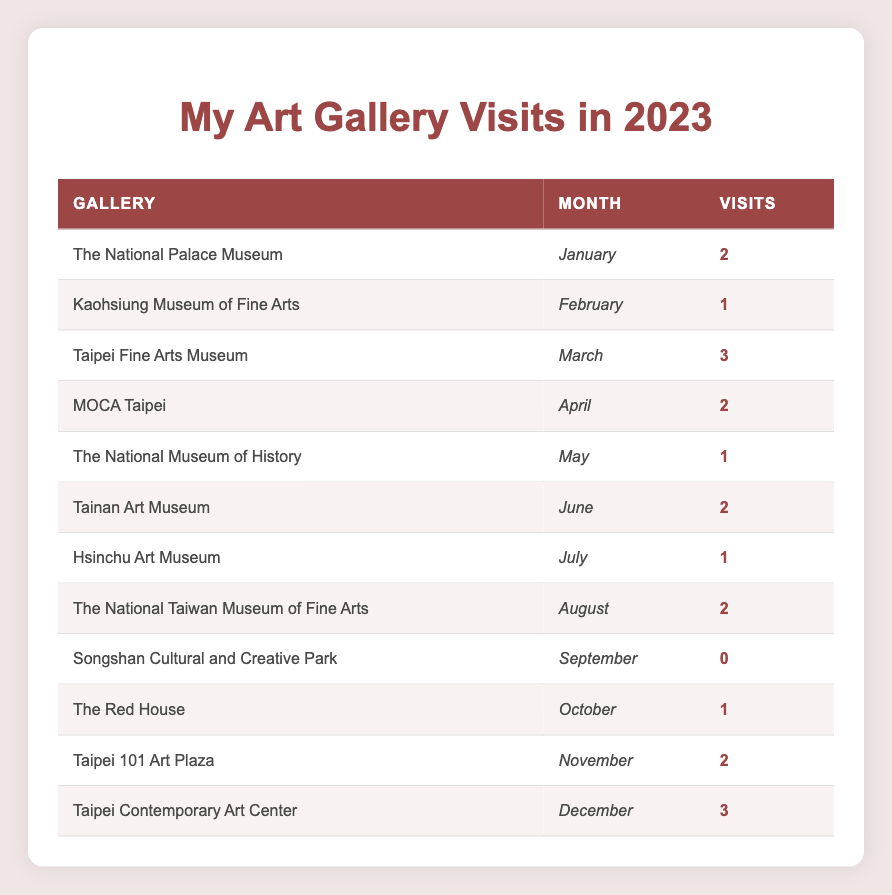What is the total number of visits Alice Chen made to art galleries from January to December? To find the total visits, I need to sum the visits from each month: 2 (Jan) + 1 (Feb) + 3 (Mar) + 2 (Apr) + 1 (May) + 2 (Jun) + 1 (Jul) + 2 (Aug) + 0 (Sep) + 1 (Oct) + 2 (Nov) + 3 (Dec) = 18 visits.
Answer: 18 Which month did Alice visit the most galleries? I can find the month with the highest number of visits by reviewing the visits for each month: March (3 visits) is the highest compared to any other month.
Answer: March Did Alice visit the Songshan Cultural and Creative Park in the past year? The table shows that there were 0 visits for Songshan Cultural and Creative Park in September, indicating no visit occurred.
Answer: No How many galleries did Alice visit with 2 or more visits in total? I count the months where visits are 2 or more: January (2), March (3), April (2), June (2), August (2), November (2), and December (3). This totals 7 months where visits were 2 or more.
Answer: 7 What was the average number of visits Alice made to galleries each month? To find the average, I divide the total number of visits (18) by the number of months (12). Thus, 18 visits / 12 months = 1.5 visits per month on average.
Answer: 1.5 Which gallery did Alice visit in October and how many times? The table shows that Alice visited The Red House in October and made 1 visit there.
Answer: The Red House, 1 visit Was the visit count higher in the second half of the year than in the first half? To verify, I sum the visits for each half: First half (January to June) = 2+1+3+2+1+2 = 11. Second half (July to December) = 1+2+0+1+2+3 = 9. The first half has higher visits than the second half.
Answer: No How many total visits were made in months where only 1 visit occurred? I identify the months with 1 visit: February (1), May (1), July (1), and October (1). Adding those gives a total of 1+1+1+1 = 4 visits.
Answer: 4 Which gallery had the least visits in a month? Reviewing the visits, Songshan Cultural and Creative Park in September had 0 visits; this is the least recorded for a gallery in any month.
Answer: Songshan Cultural and Creative Park, 0 visits 